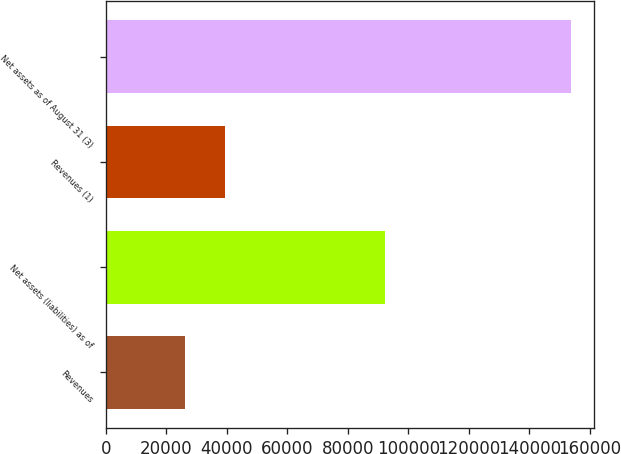Convert chart. <chart><loc_0><loc_0><loc_500><loc_500><bar_chart><fcel>Revenues<fcel>Net assets (liabilities) as of<fcel>Revenues (1)<fcel>Net assets as of August 31 (3)<nl><fcel>26247<fcel>92224<fcel>39343<fcel>153725<nl></chart> 